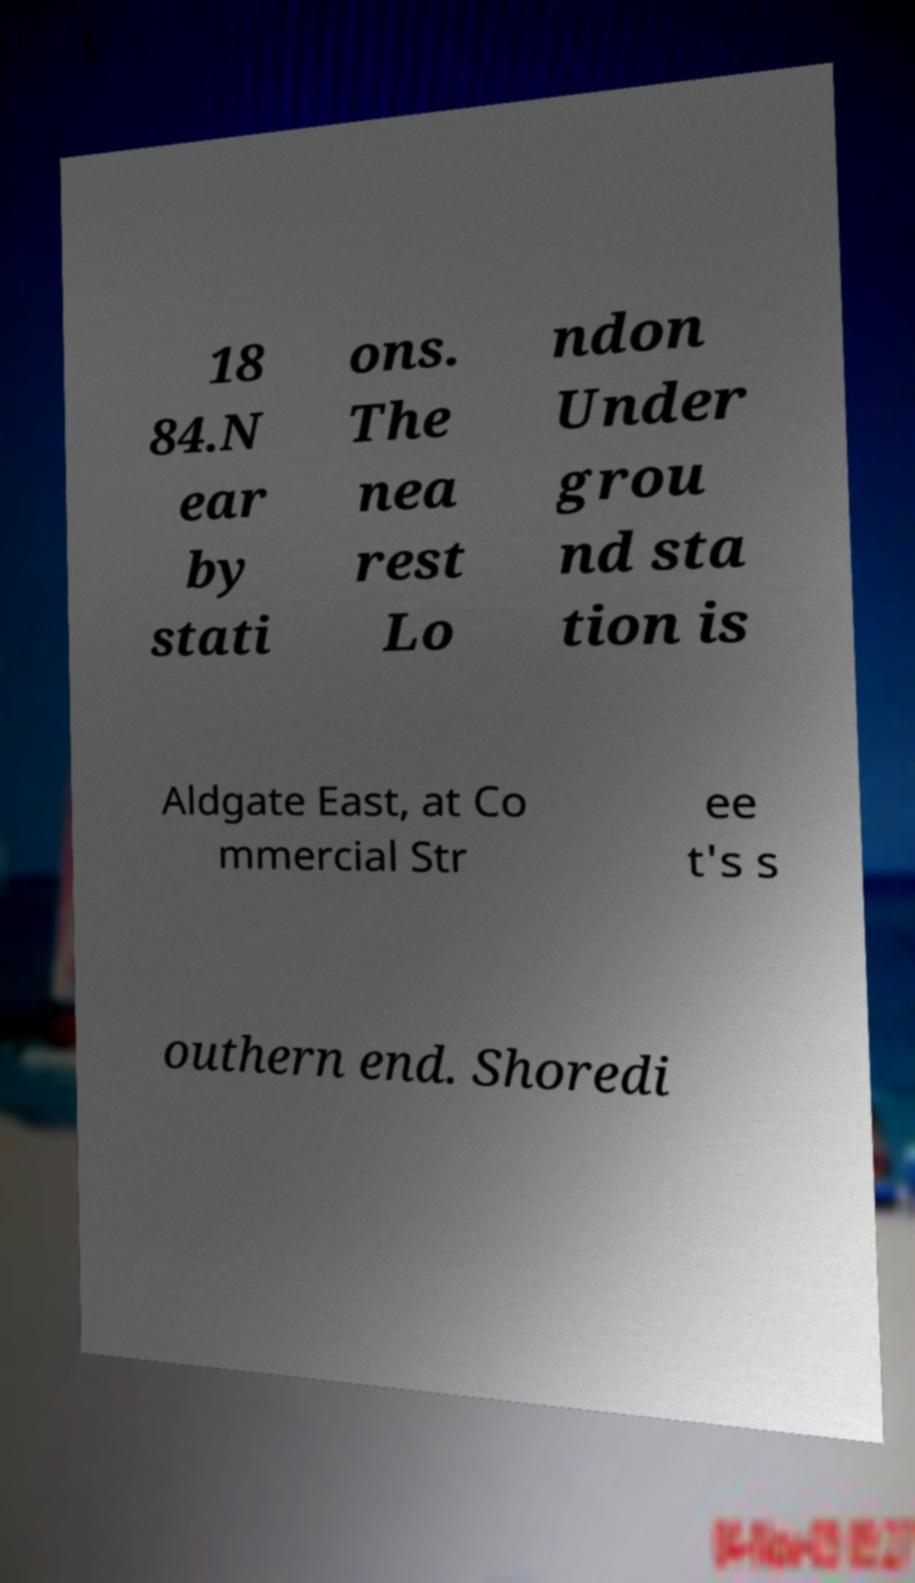There's text embedded in this image that I need extracted. Can you transcribe it verbatim? 18 84.N ear by stati ons. The nea rest Lo ndon Under grou nd sta tion is Aldgate East, at Co mmercial Str ee t's s outhern end. Shoredi 